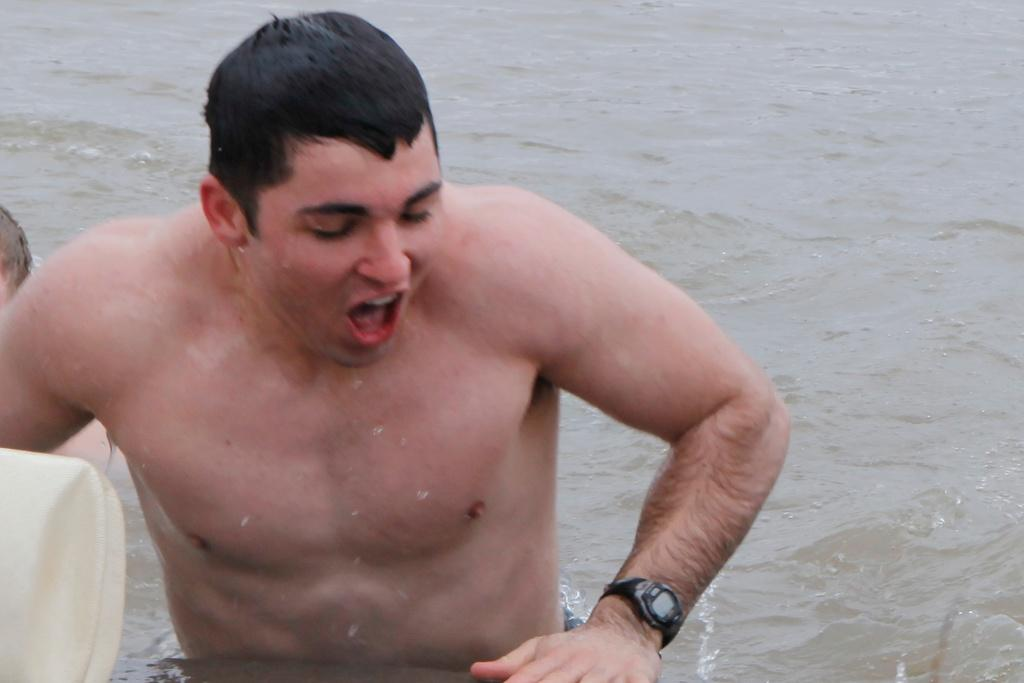Who or what is the main subject in the center of the image? There is a person in the center of the image. What is the location of the person in the image? The person is in the water. Are there any other people in the image? Yes, there is another person beside the first person. What can be seen near the two people? There is an object near the two people. What type of water body is visible at the bottom of the image? There is a river at the bottom of the image. What type of ornament is hanging from the top of the image? There is no ornament hanging from the top of the image; it is a photograph of people in the water. How many crows are visible in the image? There are no crows present in the image. 